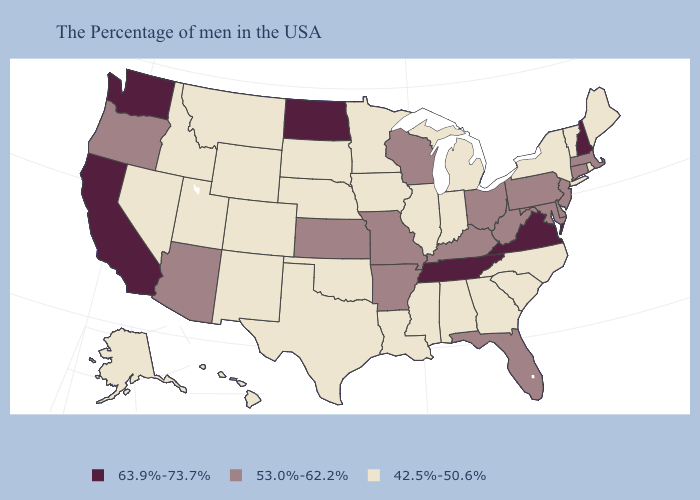Does the first symbol in the legend represent the smallest category?
Write a very short answer. No. What is the value of California?
Quick response, please. 63.9%-73.7%. Among the states that border Indiana , does Illinois have the highest value?
Be succinct. No. Name the states that have a value in the range 42.5%-50.6%?
Concise answer only. Maine, Rhode Island, Vermont, New York, North Carolina, South Carolina, Georgia, Michigan, Indiana, Alabama, Illinois, Mississippi, Louisiana, Minnesota, Iowa, Nebraska, Oklahoma, Texas, South Dakota, Wyoming, Colorado, New Mexico, Utah, Montana, Idaho, Nevada, Alaska, Hawaii. What is the value of Alabama?
Give a very brief answer. 42.5%-50.6%. Does Alaska have a lower value than Kentucky?
Give a very brief answer. Yes. Does Vermont have the same value as Wisconsin?
Short answer required. No. Among the states that border Idaho , does Nevada have the lowest value?
Answer briefly. Yes. What is the lowest value in the West?
Be succinct. 42.5%-50.6%. Does Pennsylvania have the highest value in the Northeast?
Answer briefly. No. Which states hav the highest value in the South?
Keep it brief. Virginia, Tennessee. What is the lowest value in the USA?
Give a very brief answer. 42.5%-50.6%. What is the highest value in states that border New Mexico?
Give a very brief answer. 53.0%-62.2%. Name the states that have a value in the range 42.5%-50.6%?
Answer briefly. Maine, Rhode Island, Vermont, New York, North Carolina, South Carolina, Georgia, Michigan, Indiana, Alabama, Illinois, Mississippi, Louisiana, Minnesota, Iowa, Nebraska, Oklahoma, Texas, South Dakota, Wyoming, Colorado, New Mexico, Utah, Montana, Idaho, Nevada, Alaska, Hawaii. Does Hawaii have the highest value in the West?
Short answer required. No. 